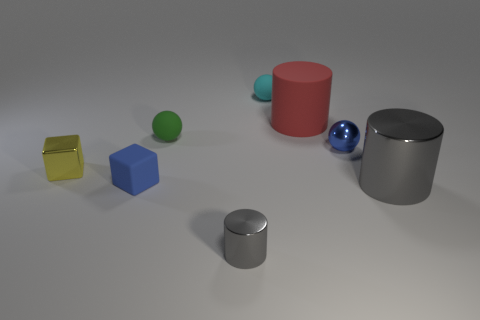Add 2 blue metallic things. How many objects exist? 10 Subtract all cylinders. How many objects are left? 5 Subtract all small cyan spheres. Subtract all metallic objects. How many objects are left? 3 Add 5 tiny blue shiny objects. How many tiny blue shiny objects are left? 6 Add 1 small blocks. How many small blocks exist? 3 Subtract 1 red cylinders. How many objects are left? 7 